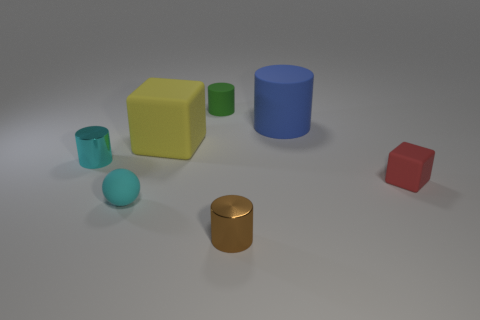Which objects in the image appear to be closest to each other? The small metallic cylinder and the red cube appear to be the closest to each other. All other objects have a noticeable separation between them. 